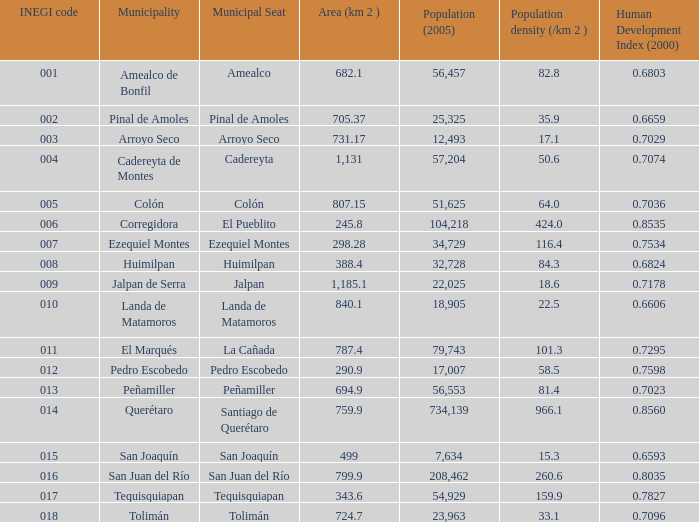Which Area (km 2 )has a Population (2005) of 57,204, and a Human Development Index (2000) smaller than 0.7074? 0.0. 